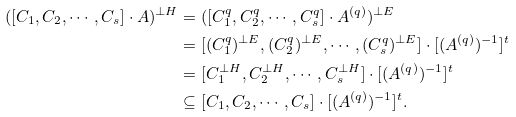<formula> <loc_0><loc_0><loc_500><loc_500>( [ C _ { 1 } , C _ { 2 } , \cdots , C _ { s } ] \cdot A ) ^ { \bot H } & = ( [ C _ { 1 } ^ { q } , C _ { 2 } ^ { q } , \cdots , C _ { s } ^ { q } ] \cdot A ^ { ( q ) } ) ^ { \bot E } \\ & = [ ( C _ { 1 } ^ { q } ) ^ { \bot E } , ( C _ { 2 } ^ { q } ) ^ { \bot E } , \cdots , ( C _ { s } ^ { q } ) ^ { \bot E } ] \cdot [ ( A ^ { ( q ) } ) ^ { - 1 } ] ^ { t } \\ & = [ C _ { 1 } ^ { \bot H } , C _ { 2 } ^ { \bot H } , \cdots , C _ { s } ^ { \bot H } ] \cdot [ ( A ^ { ( q ) } ) ^ { - 1 } ] ^ { t } \\ & \subseteq [ C _ { 1 } , C _ { 2 } , \cdots , C _ { s } ] \cdot [ ( A ^ { ( q ) } ) ^ { - 1 } ] ^ { t } .</formula> 